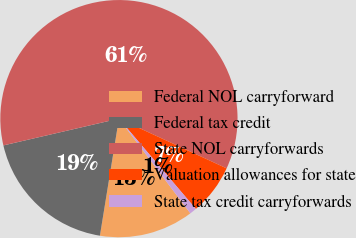Convert chart. <chart><loc_0><loc_0><loc_500><loc_500><pie_chart><fcel>Federal NOL carryforward<fcel>Federal tax credit<fcel>State NOL carryforwards<fcel>Valuation allowances for state<fcel>State tax credit carryforwards<nl><fcel>12.85%<fcel>18.81%<fcel>60.51%<fcel>6.89%<fcel>0.94%<nl></chart> 